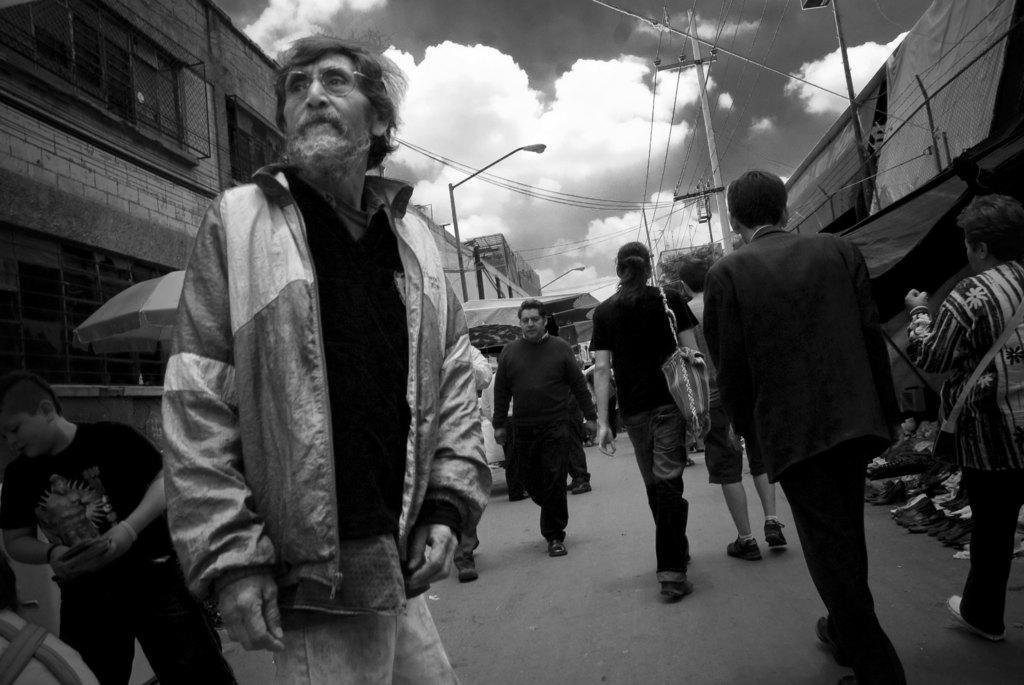Could you give a brief overview of what you see in this image? This is the black and white image and we can see some people in the street and there are few buildings and there are some objects on the floor. We can see two street lights and a power pole and at the top we can see the sky with clouds. 